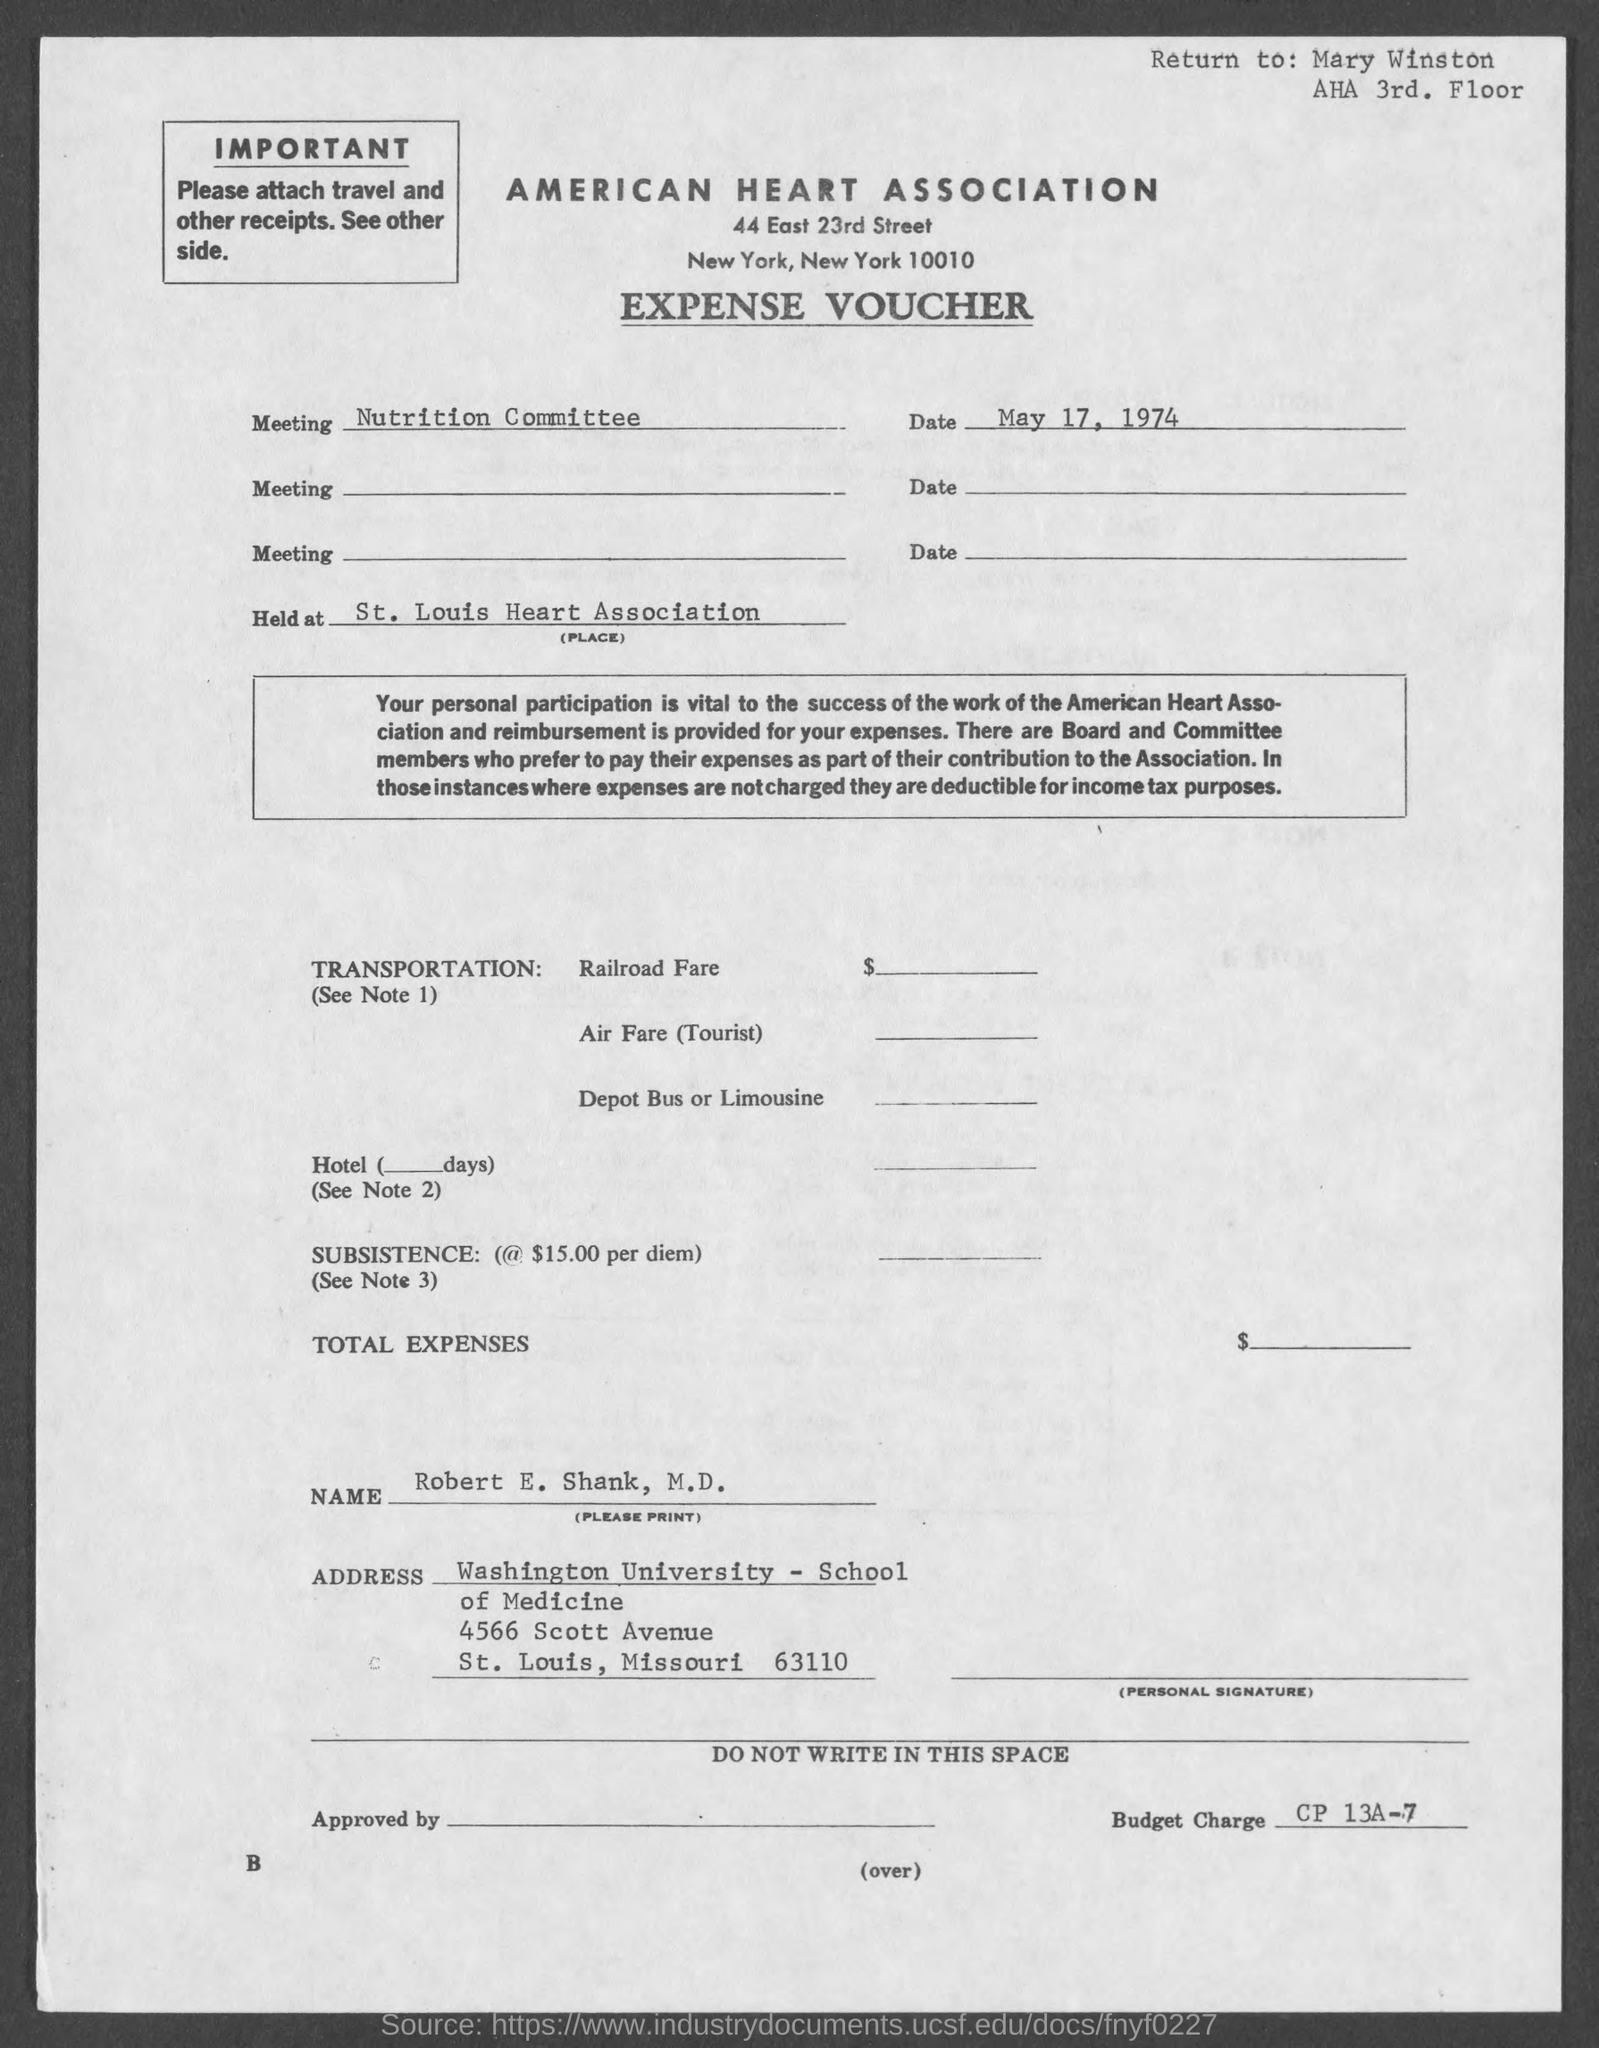Specify some key components in this picture. The street address of the American Heart Association is located at 44 East 23rd Street. The expense voucher is dated May 17, 1974. 